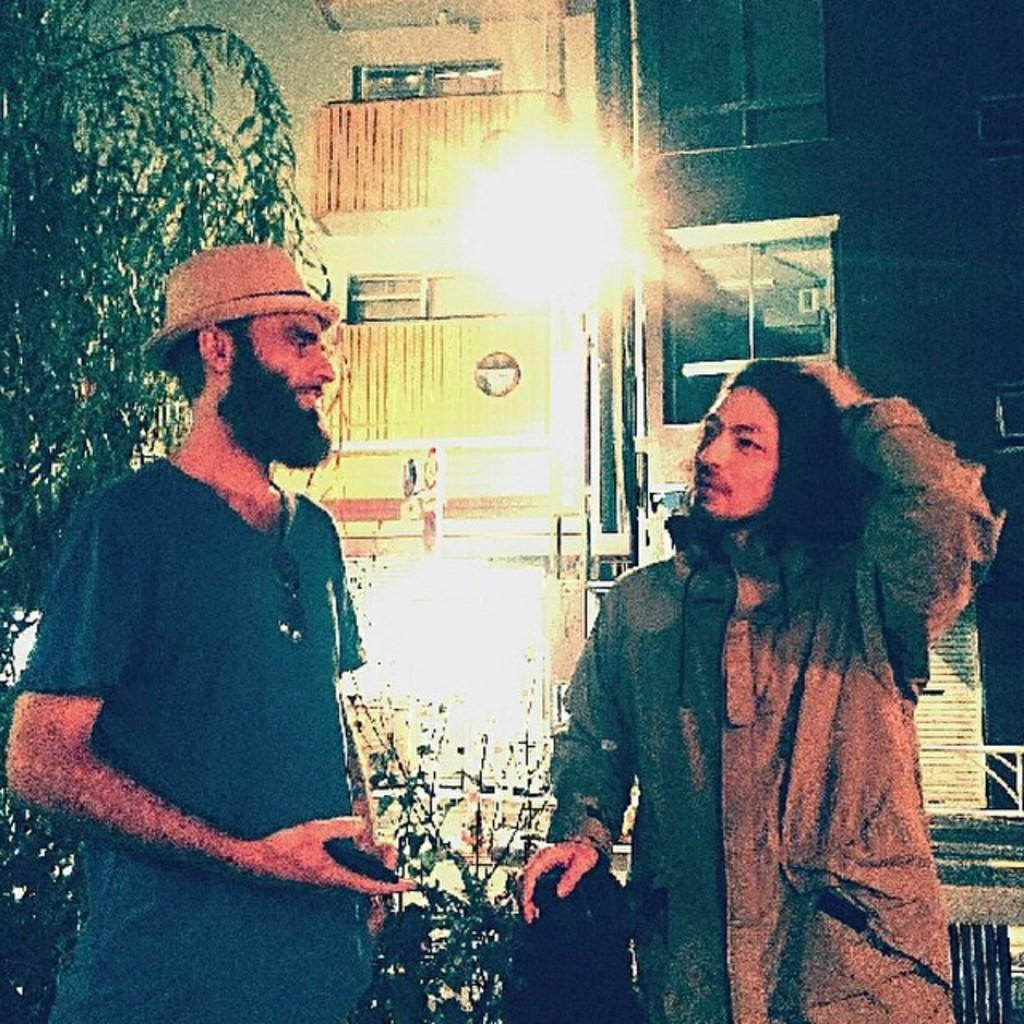How many people are visible in the image? There are two persons standing on the road in the image. What can be seen in the background of the image? There are buildings, trees, and a fence in the background of the image. Can you describe the lighting conditions in the image? The image may have been taken during the night, as it appears to be dark. What type of powder is being used by the persons in the image? There is no powder visible in the image; the two persons are simply standing on the road. What hobbies do the persons in the image share? There is no information about the hobbies of the persons in the image, as the focus is on their presence on the road and the background elements. 